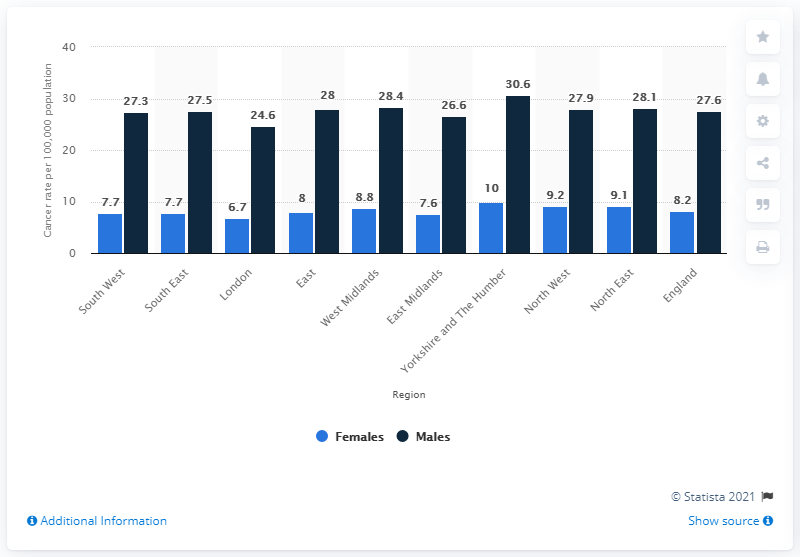Outline some significant characteristics in this image. In 2017, the region of Yorkshire and The Humber was affected by the COVID-19 pandemic the most, with the highest number of cases and deaths. 